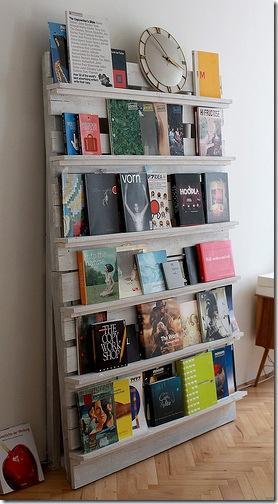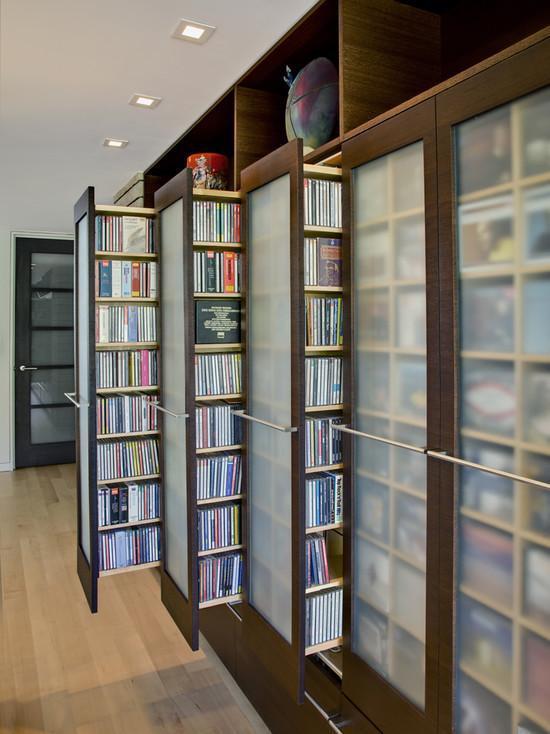The first image is the image on the left, the second image is the image on the right. Examine the images to the left and right. Is the description "There are no fewer than four framed images in the image on the right." accurate? Answer yes or no. No. 